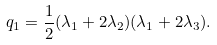<formula> <loc_0><loc_0><loc_500><loc_500>q _ { 1 } = \frac { 1 } { 2 } ( \lambda _ { 1 } + 2 \lambda _ { 2 } ) ( \lambda _ { 1 } + 2 \lambda _ { 3 } ) .</formula> 